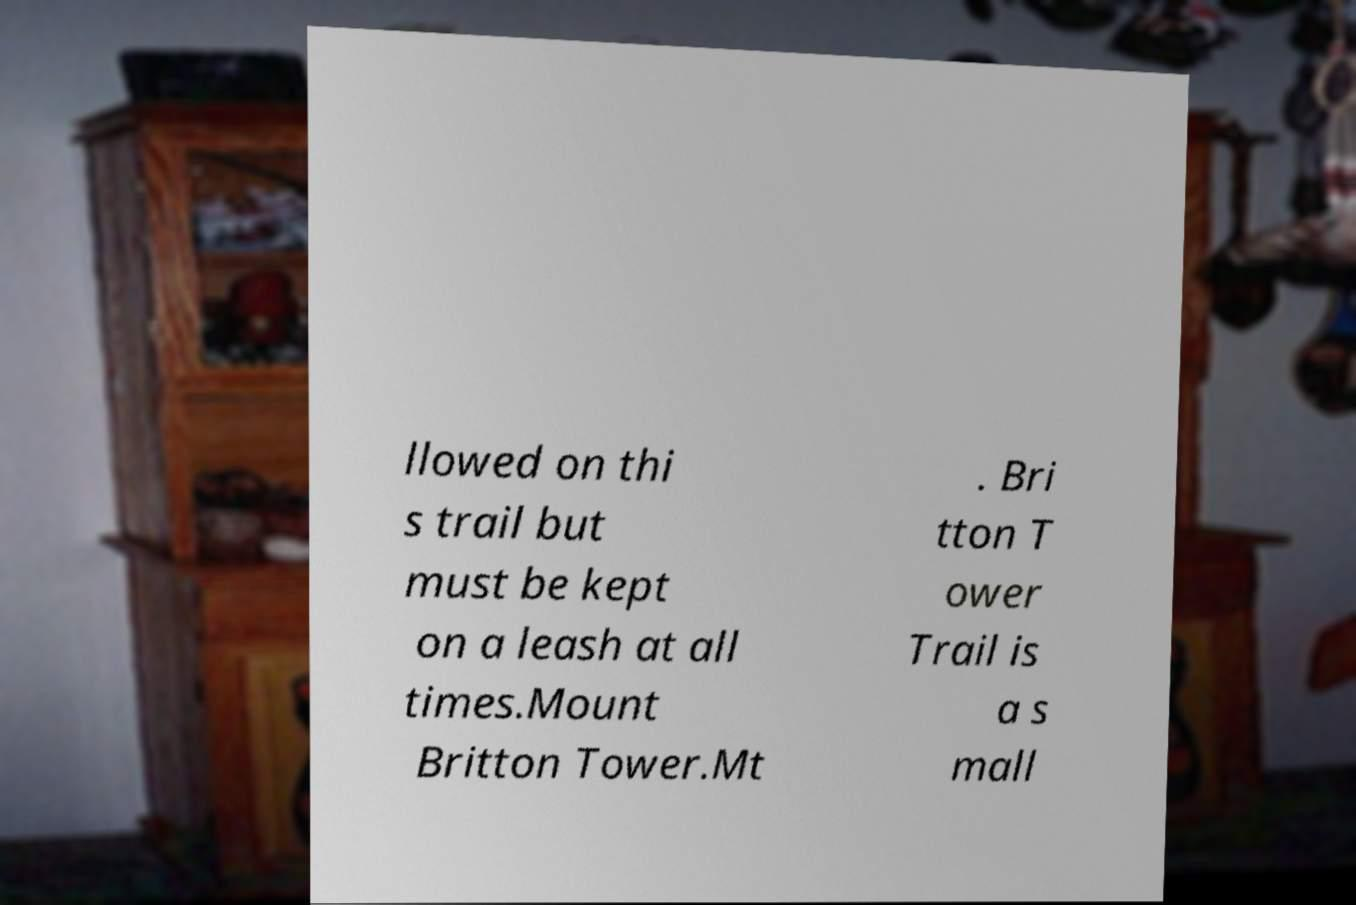For documentation purposes, I need the text within this image transcribed. Could you provide that? llowed on thi s trail but must be kept on a leash at all times.Mount Britton Tower.Mt . Bri tton T ower Trail is a s mall 